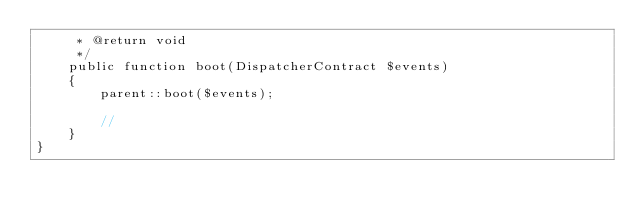<code> <loc_0><loc_0><loc_500><loc_500><_PHP_>     * @return void
     */
    public function boot(DispatcherContract $events)
    {
        parent::boot($events);

        //
    }
}
</code> 